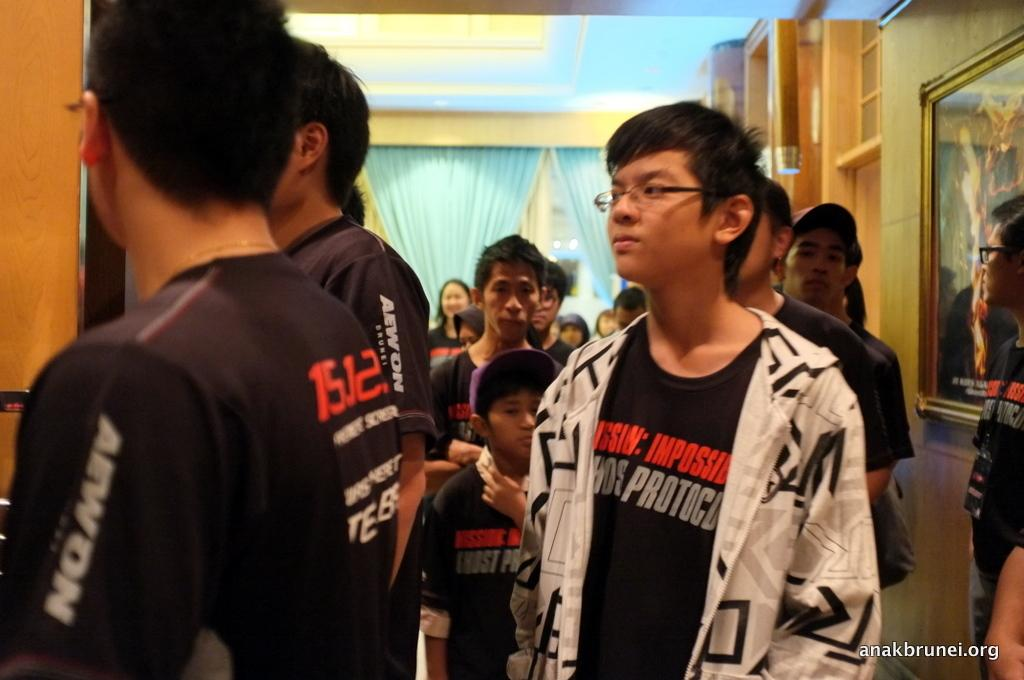How many people are present in the image? There are many people standing in the image. What can be seen on the right side of the image? There is a painting on the wall on the right side of the image. What type of window treatment is visible in the image? There are curtains visible in the image. What part of the room is visible at the top of the image? The ceiling is visible in the image. What is present on the ceiling in the image? There is a light on the ceiling. What type of lettuce is being served on the cake in the image? There is no cake or lettuce present in the image. How does the snail move across the floor in the image? There is no snail present in the image. 